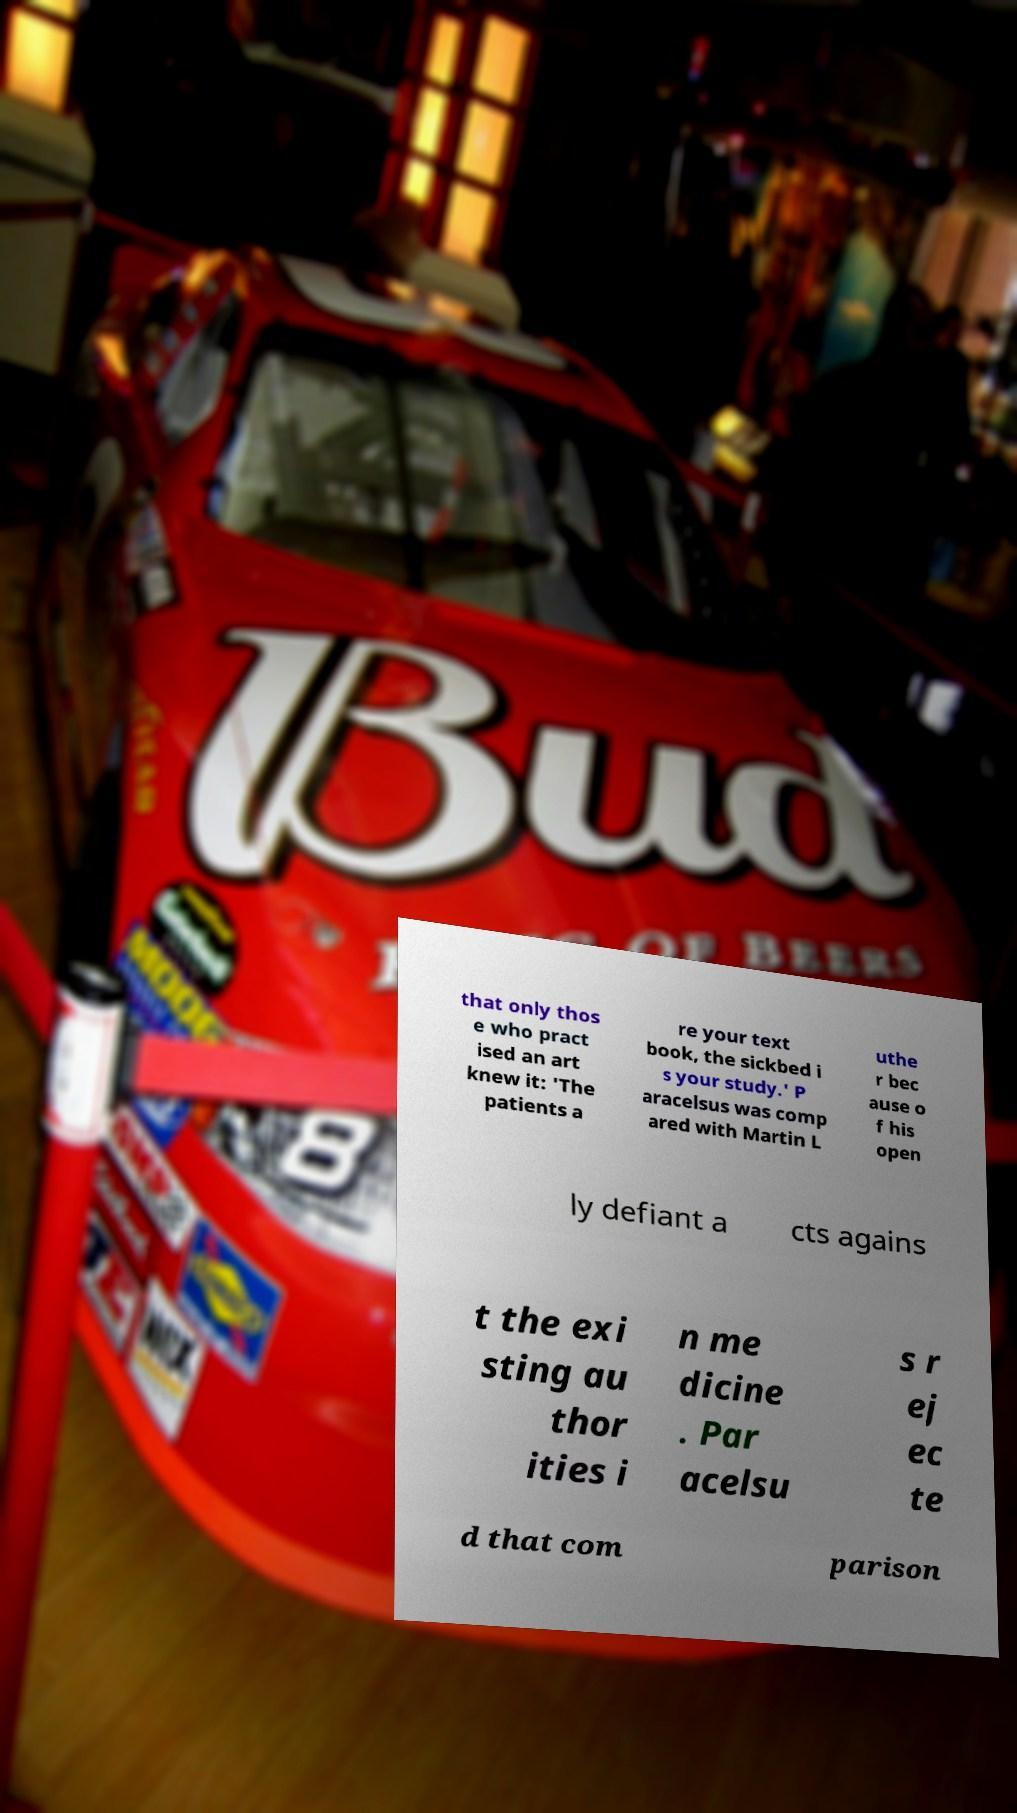I need the written content from this picture converted into text. Can you do that? that only thos e who pract ised an art knew it: 'The patients a re your text book, the sickbed i s your study.' P aracelsus was comp ared with Martin L uthe r bec ause o f his open ly defiant a cts agains t the exi sting au thor ities i n me dicine . Par acelsu s r ej ec te d that com parison 